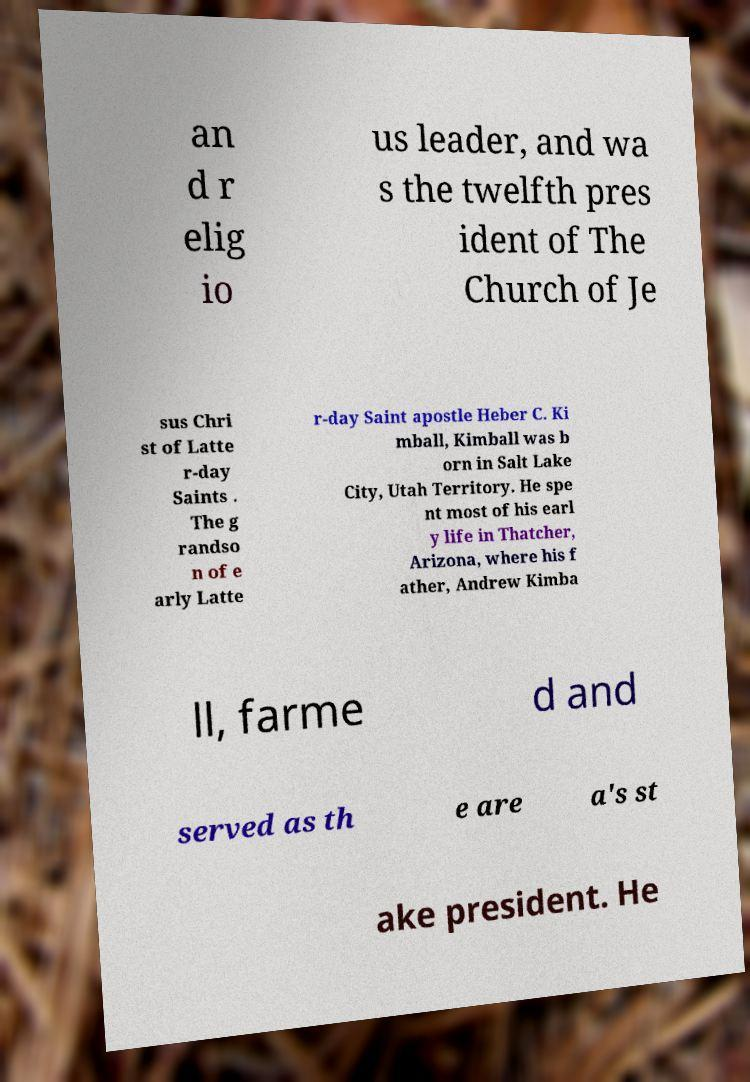Please identify and transcribe the text found in this image. an d r elig io us leader, and wa s the twelfth pres ident of The Church of Je sus Chri st of Latte r-day Saints . The g randso n of e arly Latte r-day Saint apostle Heber C. Ki mball, Kimball was b orn in Salt Lake City, Utah Territory. He spe nt most of his earl y life in Thatcher, Arizona, where his f ather, Andrew Kimba ll, farme d and served as th e are a's st ake president. He 